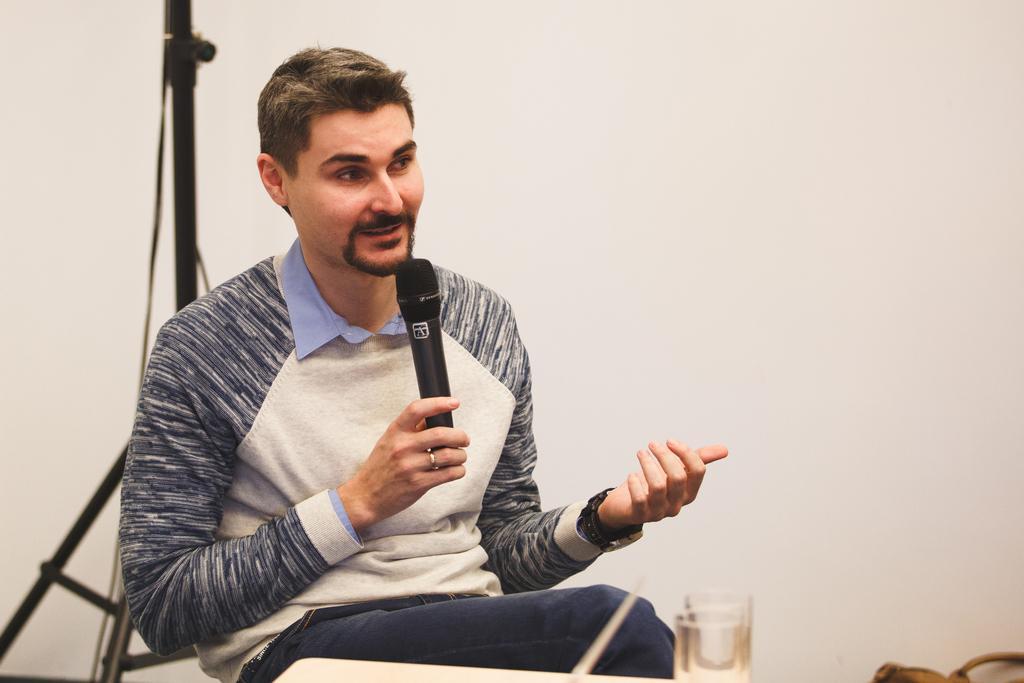Please provide a concise description of this image. In the picture we can see a man sitting in the chair and talking something holding a microphone and in front of him we can see two glasses on the table and behind him we can see a tripod stand and behind it we can see a wall which is white in color. 